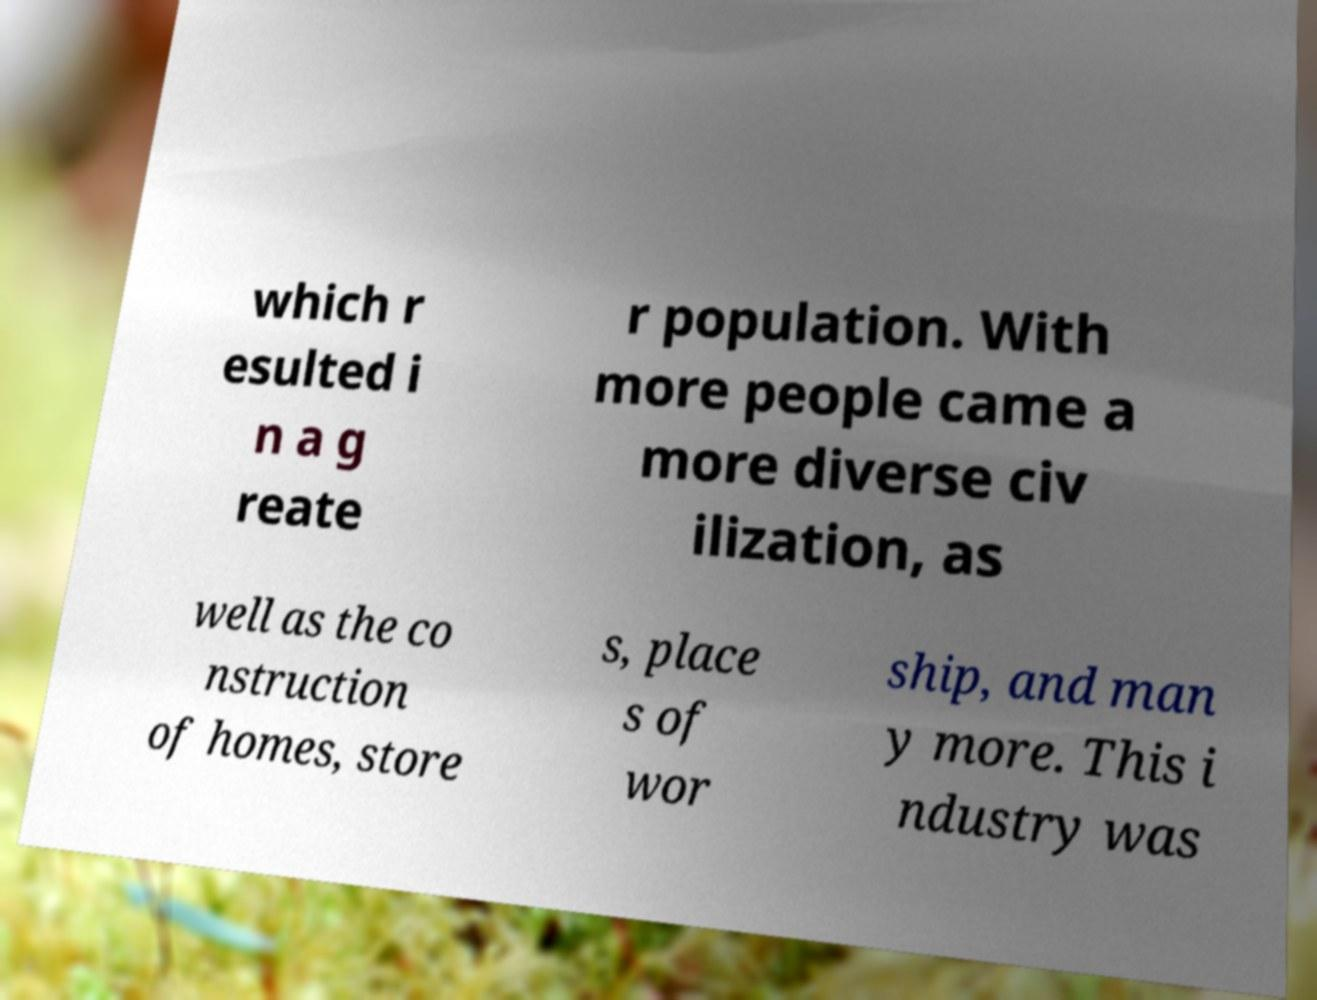For documentation purposes, I need the text within this image transcribed. Could you provide that? which r esulted i n a g reate r population. With more people came a more diverse civ ilization, as well as the co nstruction of homes, store s, place s of wor ship, and man y more. This i ndustry was 